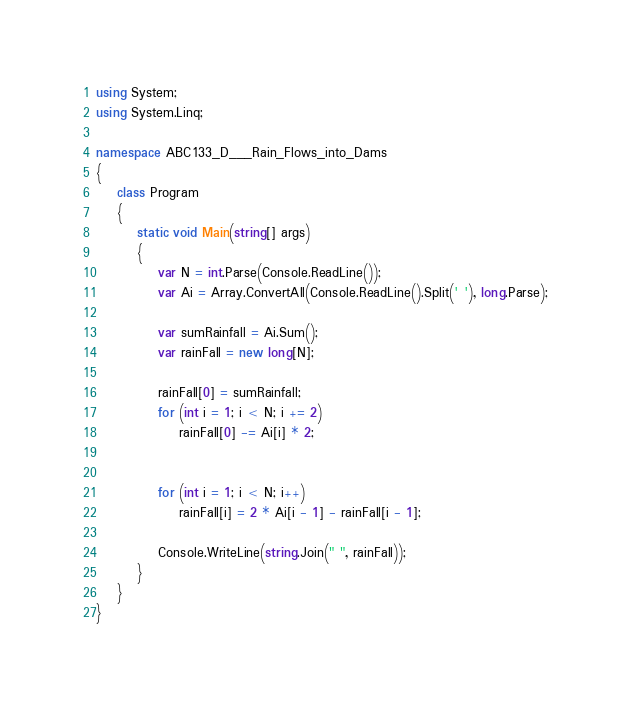<code> <loc_0><loc_0><loc_500><loc_500><_C#_>using System;
using System.Linq;

namespace ABC133_D___Rain_Flows_into_Dams
{
    class Program
    {
        static void Main(string[] args)
        {
            var N = int.Parse(Console.ReadLine());
            var Ai = Array.ConvertAll(Console.ReadLine().Split(' '), long.Parse);

            var sumRainfall = Ai.Sum();
            var rainFall = new long[N];

            rainFall[0] = sumRainfall;
            for (int i = 1; i < N; i += 2)
                rainFall[0] -= Ai[i] * 2;


            for (int i = 1; i < N; i++)
                rainFall[i] = 2 * Ai[i - 1] - rainFall[i - 1];

            Console.WriteLine(string.Join(" ", rainFall));
        }
    }
}
</code> 